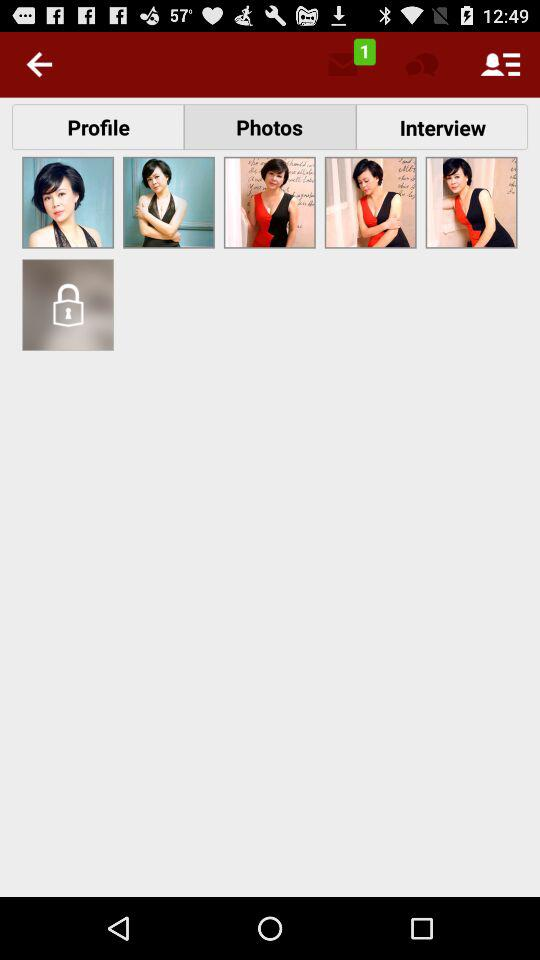How many unread messages are there? The number of unread messages is 1. 